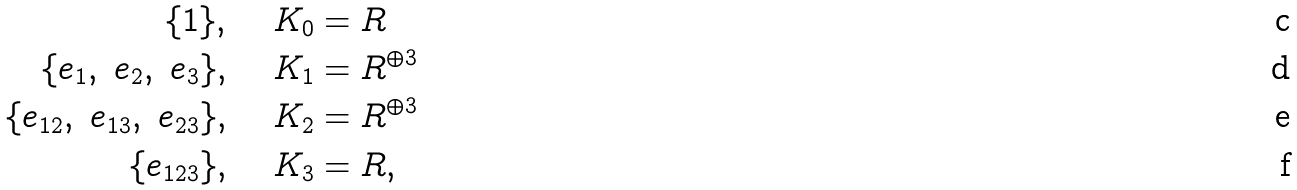<formula> <loc_0><loc_0><loc_500><loc_500>\{ 1 \} , & \quad \ K _ { 0 } = R \\ \{ e _ { 1 } , \ e _ { 2 } , \ e _ { 3 } \} , & \quad \ K _ { 1 } = R ^ { \oplus 3 } \\ \{ e _ { 1 2 } , \ e _ { 1 3 } , \ e _ { 2 3 } \} , & \quad \ K _ { 2 } = R ^ { \oplus 3 } \\ \{ e _ { 1 2 3 } \} , & \quad \ K _ { 3 } = R ,</formula> 